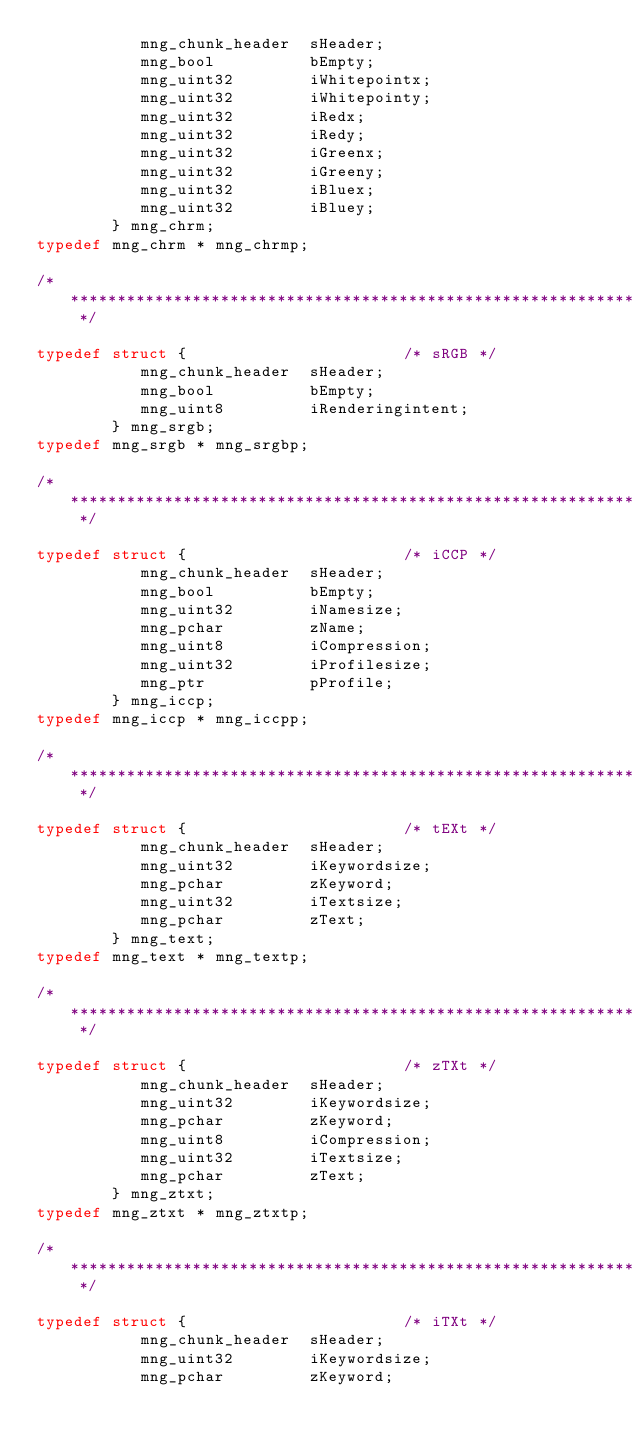<code> <loc_0><loc_0><loc_500><loc_500><_C_>           mng_chunk_header  sHeader;
           mng_bool          bEmpty;
           mng_uint32        iWhitepointx;
           mng_uint32        iWhitepointy;
           mng_uint32        iRedx;
           mng_uint32        iRedy;
           mng_uint32        iGreenx;
           mng_uint32        iGreeny;
           mng_uint32        iBluex;
           mng_uint32        iBluey;
        } mng_chrm;
typedef mng_chrm * mng_chrmp;

/* ************************************************************************** */

typedef struct {                       /* sRGB */
           mng_chunk_header  sHeader;
           mng_bool          bEmpty;
           mng_uint8         iRenderingintent;
        } mng_srgb;
typedef mng_srgb * mng_srgbp;

/* ************************************************************************** */

typedef struct {                       /* iCCP */
           mng_chunk_header  sHeader;
           mng_bool          bEmpty;
           mng_uint32        iNamesize;
           mng_pchar         zName;
           mng_uint8         iCompression;
           mng_uint32        iProfilesize;
           mng_ptr           pProfile;
        } mng_iccp;
typedef mng_iccp * mng_iccpp;

/* ************************************************************************** */

typedef struct {                       /* tEXt */
           mng_chunk_header  sHeader;
           mng_uint32        iKeywordsize;
           mng_pchar         zKeyword;
           mng_uint32        iTextsize;
           mng_pchar         zText;
        } mng_text;
typedef mng_text * mng_textp;

/* ************************************************************************** */

typedef struct {                       /* zTXt */
           mng_chunk_header  sHeader;
           mng_uint32        iKeywordsize;
           mng_pchar         zKeyword;
           mng_uint8         iCompression;
           mng_uint32        iTextsize;
           mng_pchar         zText;
        } mng_ztxt;
typedef mng_ztxt * mng_ztxtp;

/* ************************************************************************** */

typedef struct {                       /* iTXt */
           mng_chunk_header  sHeader;
           mng_uint32        iKeywordsize;
           mng_pchar         zKeyword;</code> 